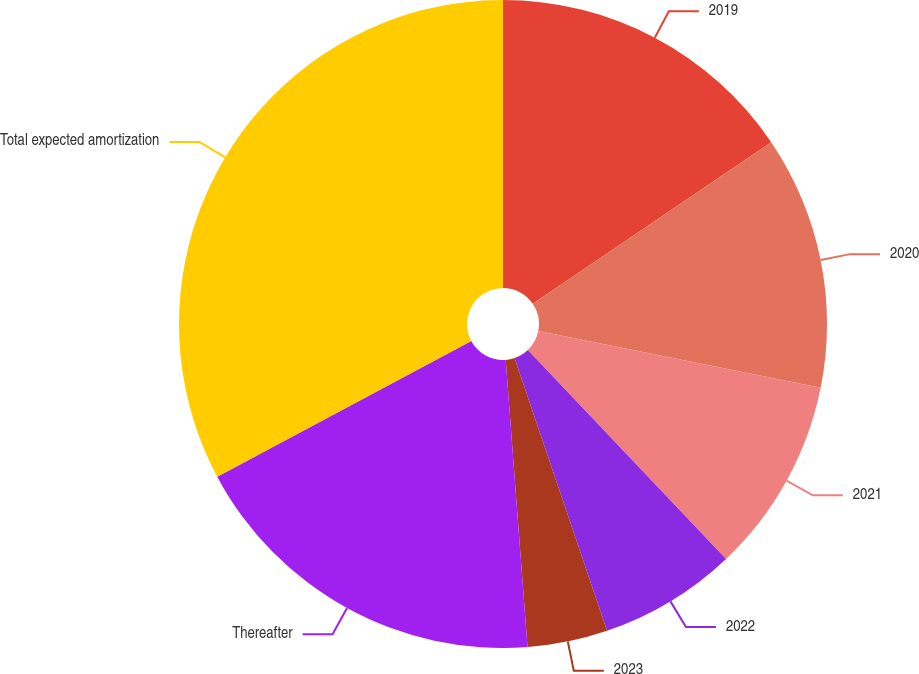<chart> <loc_0><loc_0><loc_500><loc_500><pie_chart><fcel>2019<fcel>2020<fcel>2021<fcel>2022<fcel>2023<fcel>Thereafter<fcel>Total expected amortization<nl><fcel>15.52%<fcel>12.64%<fcel>9.76%<fcel>6.88%<fcel>4.0%<fcel>18.4%<fcel>32.81%<nl></chart> 